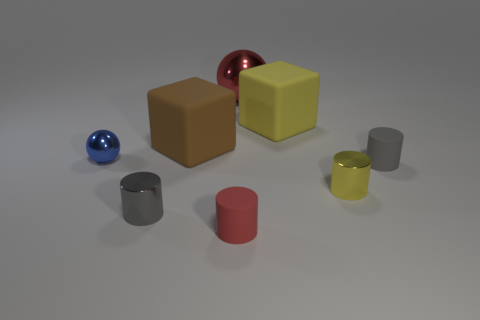Is the number of gray metallic cylinders left of the small gray shiny thing greater than the number of big metallic things right of the red sphere?
Offer a very short reply. No. What material is the cylinder that is the same color as the large metallic thing?
Your answer should be very brief. Rubber. Are there any other things that have the same shape as the red matte thing?
Keep it short and to the point. Yes. What material is the thing that is to the left of the large brown rubber block and behind the small gray rubber object?
Make the answer very short. Metal. Is the small blue ball made of the same material as the ball behind the blue object?
Make the answer very short. Yes. Is there any other thing that has the same size as the gray rubber cylinder?
Your response must be concise. Yes. What number of things are either small blue metallic things or large matte things behind the gray rubber cylinder?
Ensure brevity in your answer.  3. Does the gray cylinder that is to the right of the small red rubber cylinder have the same size as the sphere that is to the left of the red ball?
Offer a terse response. Yes. How many other things are the same color as the tiny shiny ball?
Your answer should be very brief. 0. Is the size of the gray metallic object the same as the block that is on the left side of the large red object?
Provide a short and direct response. No. 